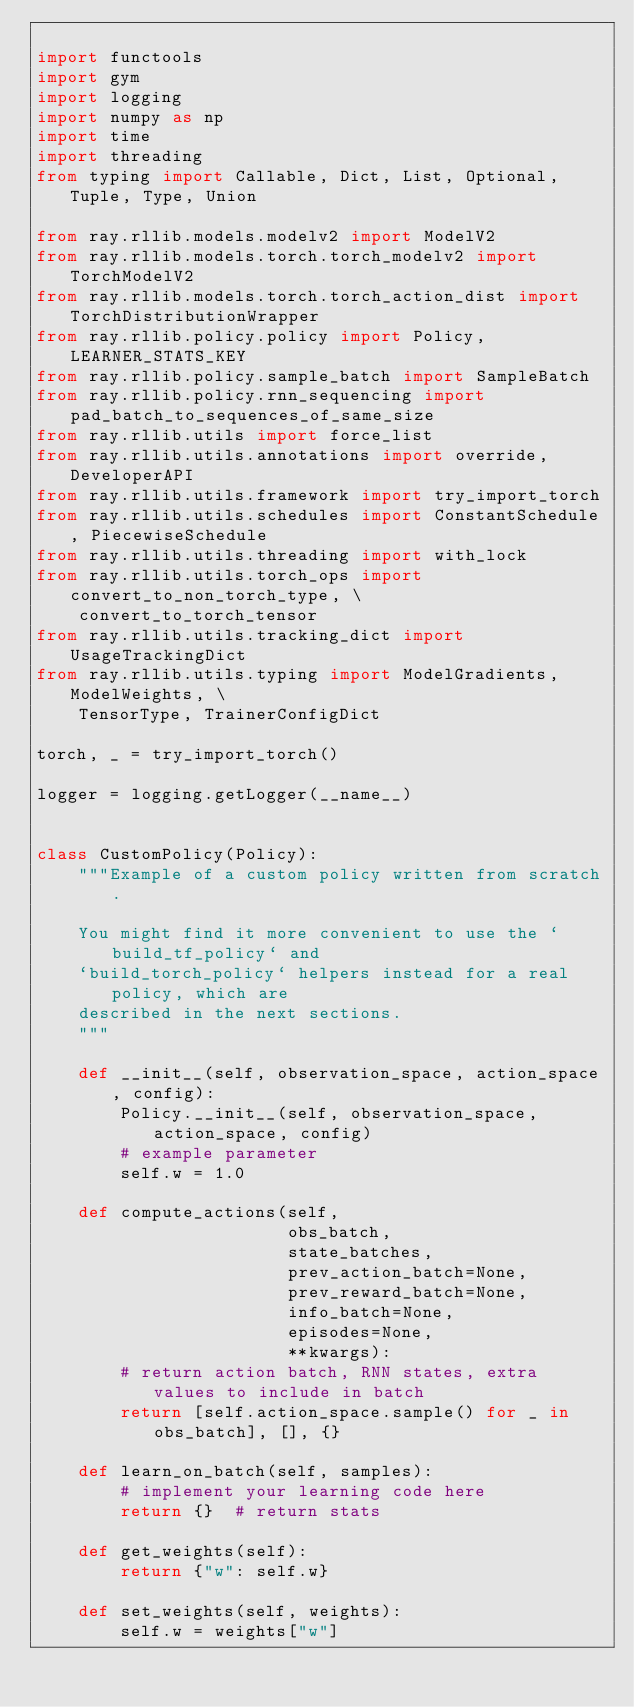Convert code to text. <code><loc_0><loc_0><loc_500><loc_500><_Python_>
import functools
import gym
import logging
import numpy as np
import time
import threading
from typing import Callable, Dict, List, Optional, Tuple, Type, Union

from ray.rllib.models.modelv2 import ModelV2
from ray.rllib.models.torch.torch_modelv2 import TorchModelV2
from ray.rllib.models.torch.torch_action_dist import TorchDistributionWrapper
from ray.rllib.policy.policy import Policy, LEARNER_STATS_KEY
from ray.rllib.policy.sample_batch import SampleBatch
from ray.rllib.policy.rnn_sequencing import pad_batch_to_sequences_of_same_size
from ray.rllib.utils import force_list
from ray.rllib.utils.annotations import override, DeveloperAPI
from ray.rllib.utils.framework import try_import_torch
from ray.rllib.utils.schedules import ConstantSchedule, PiecewiseSchedule
from ray.rllib.utils.threading import with_lock
from ray.rllib.utils.torch_ops import convert_to_non_torch_type, \
    convert_to_torch_tensor
from ray.rllib.utils.tracking_dict import UsageTrackingDict
from ray.rllib.utils.typing import ModelGradients, ModelWeights, \
    TensorType, TrainerConfigDict

torch, _ = try_import_torch()

logger = logging.getLogger(__name__)


class CustomPolicy(Policy):
    """Example of a custom policy written from scratch.

    You might find it more convenient to use the `build_tf_policy` and
    `build_torch_policy` helpers instead for a real policy, which are
    described in the next sections.
    """

    def __init__(self, observation_space, action_space, config):
        Policy.__init__(self, observation_space, action_space, config)
        # example parameter
        self.w = 1.0

    def compute_actions(self,
                        obs_batch,
                        state_batches,
                        prev_action_batch=None,
                        prev_reward_batch=None,
                        info_batch=None,
                        episodes=None,
                        **kwargs):
        # return action batch, RNN states, extra values to include in batch
        return [self.action_space.sample() for _ in obs_batch], [], {}

    def learn_on_batch(self, samples):
        # implement your learning code here
        return {}  # return stats

    def get_weights(self):
        return {"w": self.w}

    def set_weights(self, weights):
        self.w = weights["w"]
</code> 